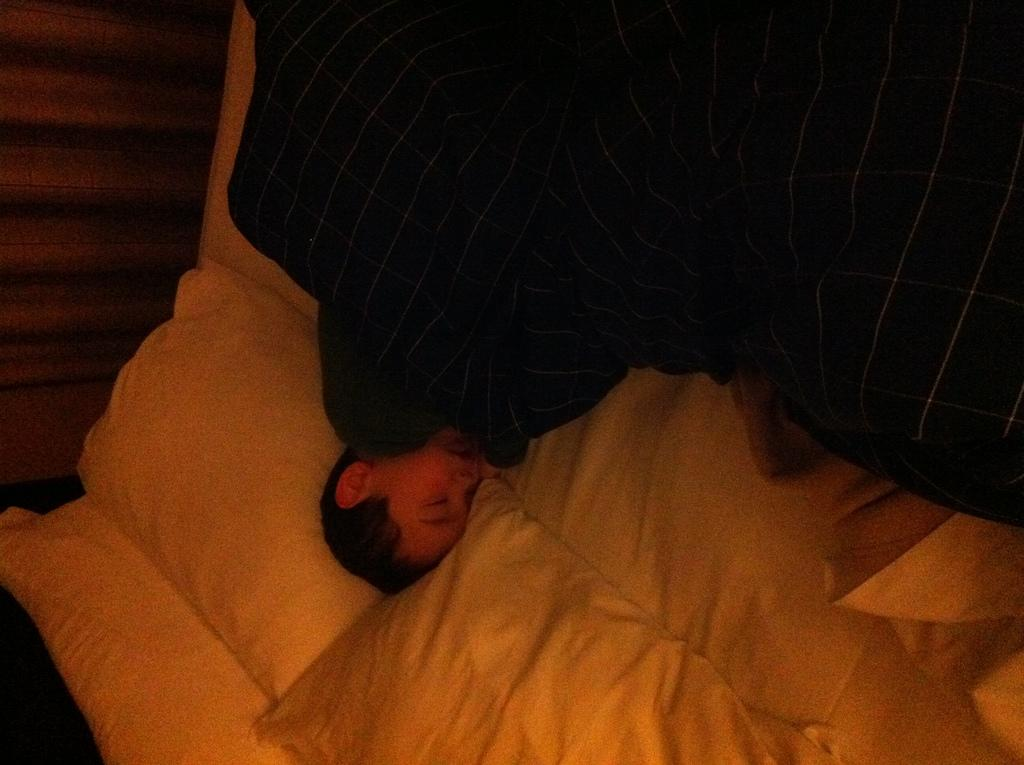What is the main subject of the image? There is a person in the image. What is the person doing in the image? The person is in bed. Can you see any goats or badges in the image? No, there are no goats or badges present in the image. Are there any boats visible in the image? No, there are no boats visible in the image. 